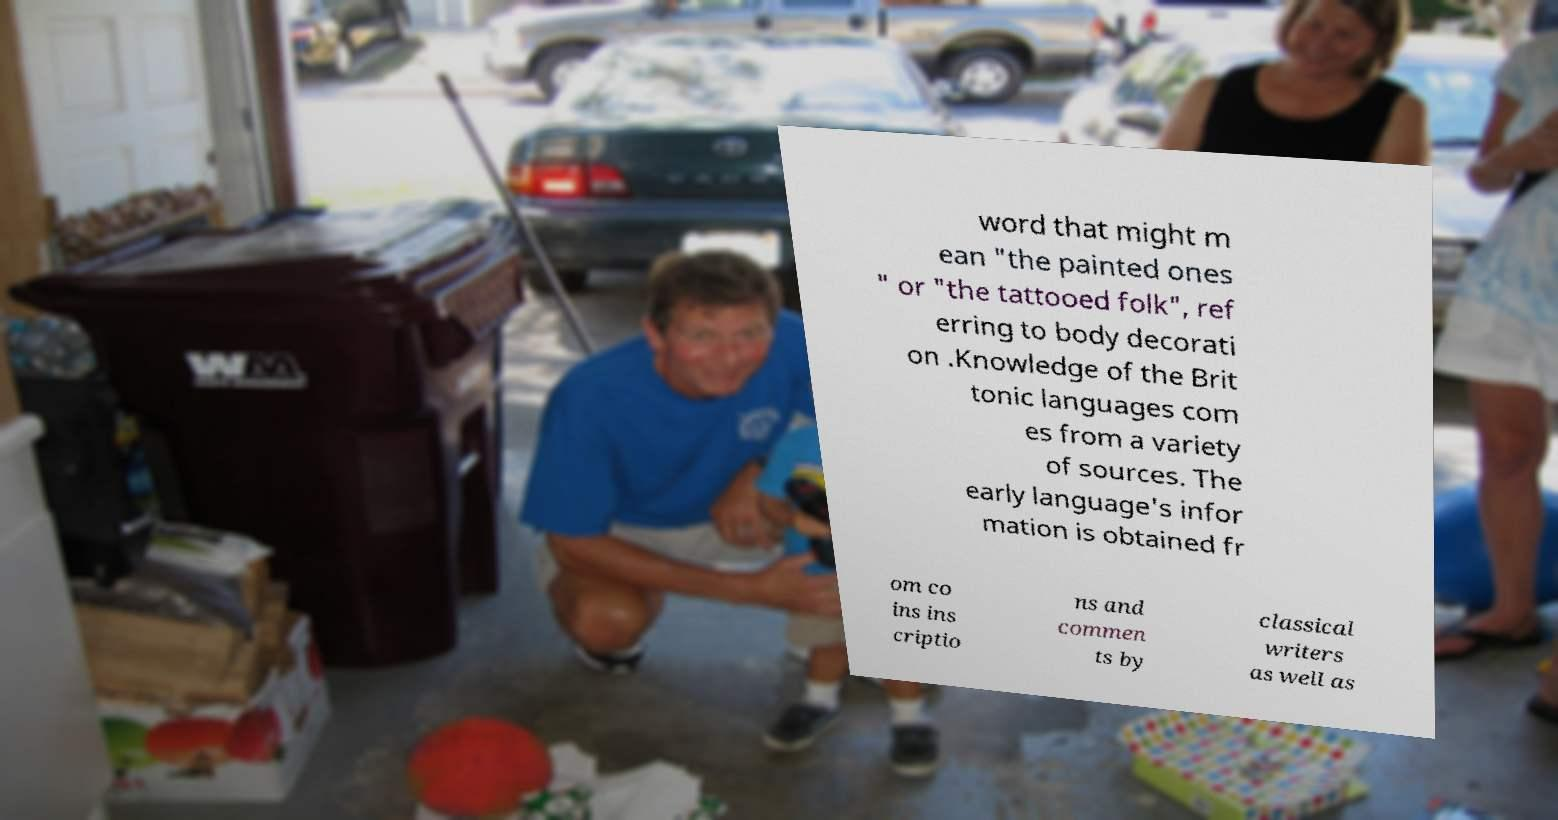I need the written content from this picture converted into text. Can you do that? word that might m ean "the painted ones " or "the tattooed folk", ref erring to body decorati on .Knowledge of the Brit tonic languages com es from a variety of sources. The early language's infor mation is obtained fr om co ins ins criptio ns and commen ts by classical writers as well as 